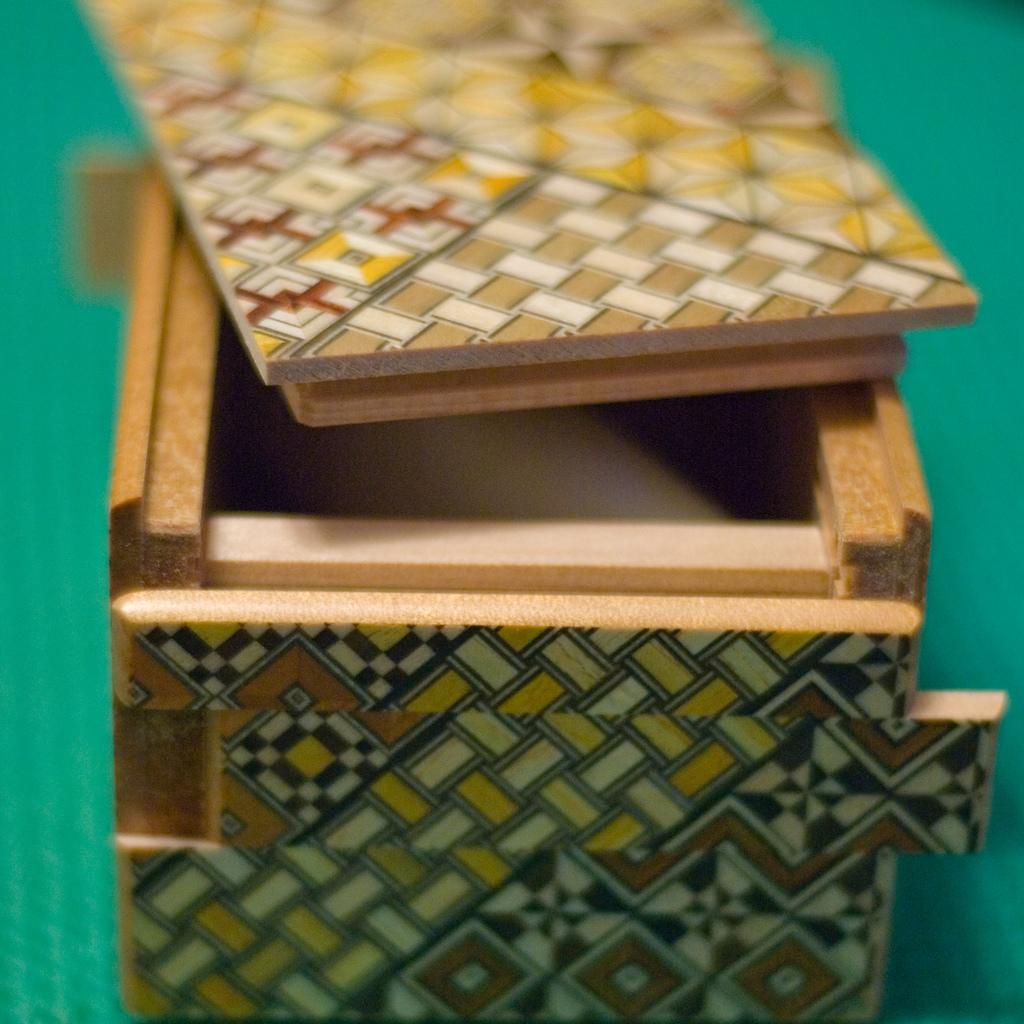What is the main object in the image? There is a wooden box in the image. What is on top of the wooden box? The wooden box has wooden planks on top. What can be observed on the wooden planks? The wooden planks have a design on them. What color is the background of the image? The background of the image is green in color. Can you see any points in the sky in the image? There is no sky visible in the image, so it's not possible to see any points in the sky. Is there a rifle present in the image? There is no rifle present in the image. 